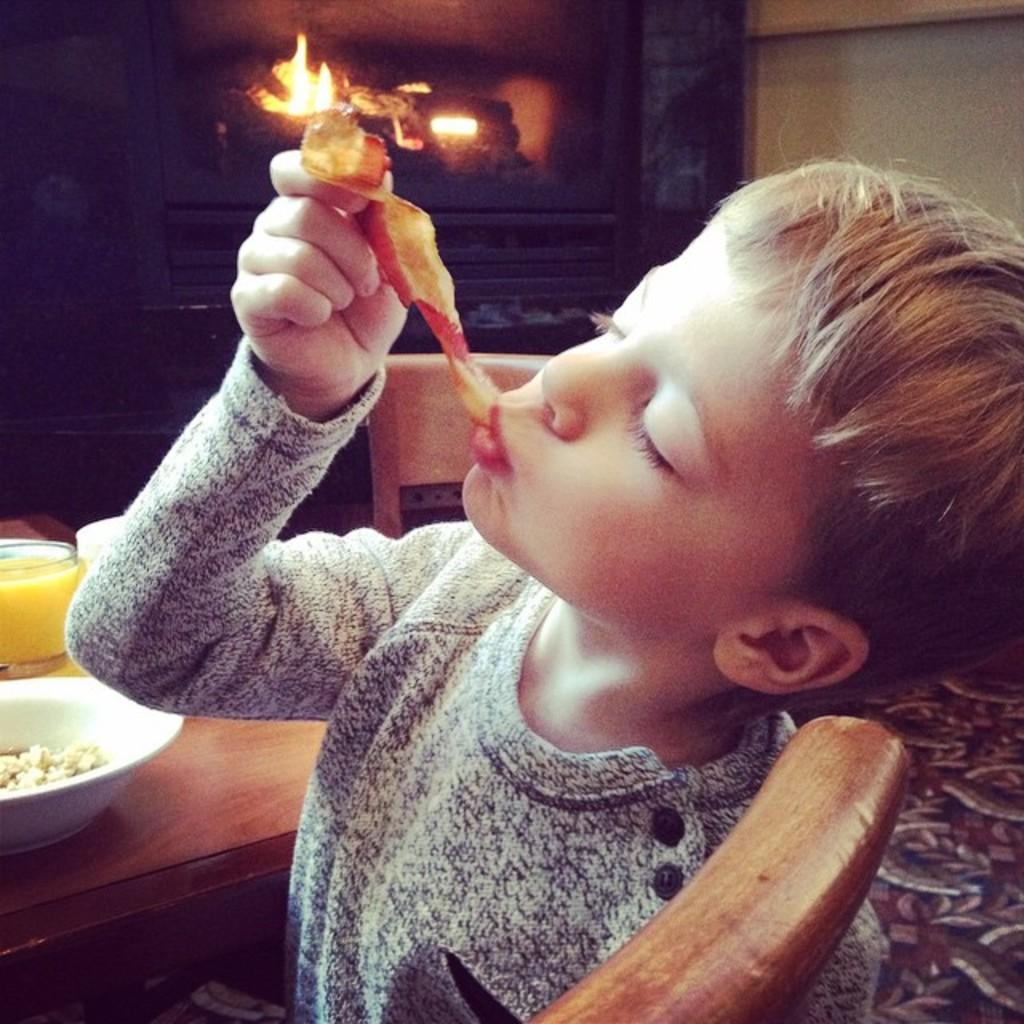Who is the main subject in the image? There is a boy in the image. What is the boy doing in the image? The boy is eating food. Where is the table located in the image? The table is on the left side of the image. How many chairs are visible in the image? There are two chairs in the image. What can be seen in the background of the image? There is a wall in the background of the image. What type of blade is being used by the boy to eat his food in the image? There is no blade visible in the image; the boy is likely using a utensil like a fork or spoon to eat his food. 